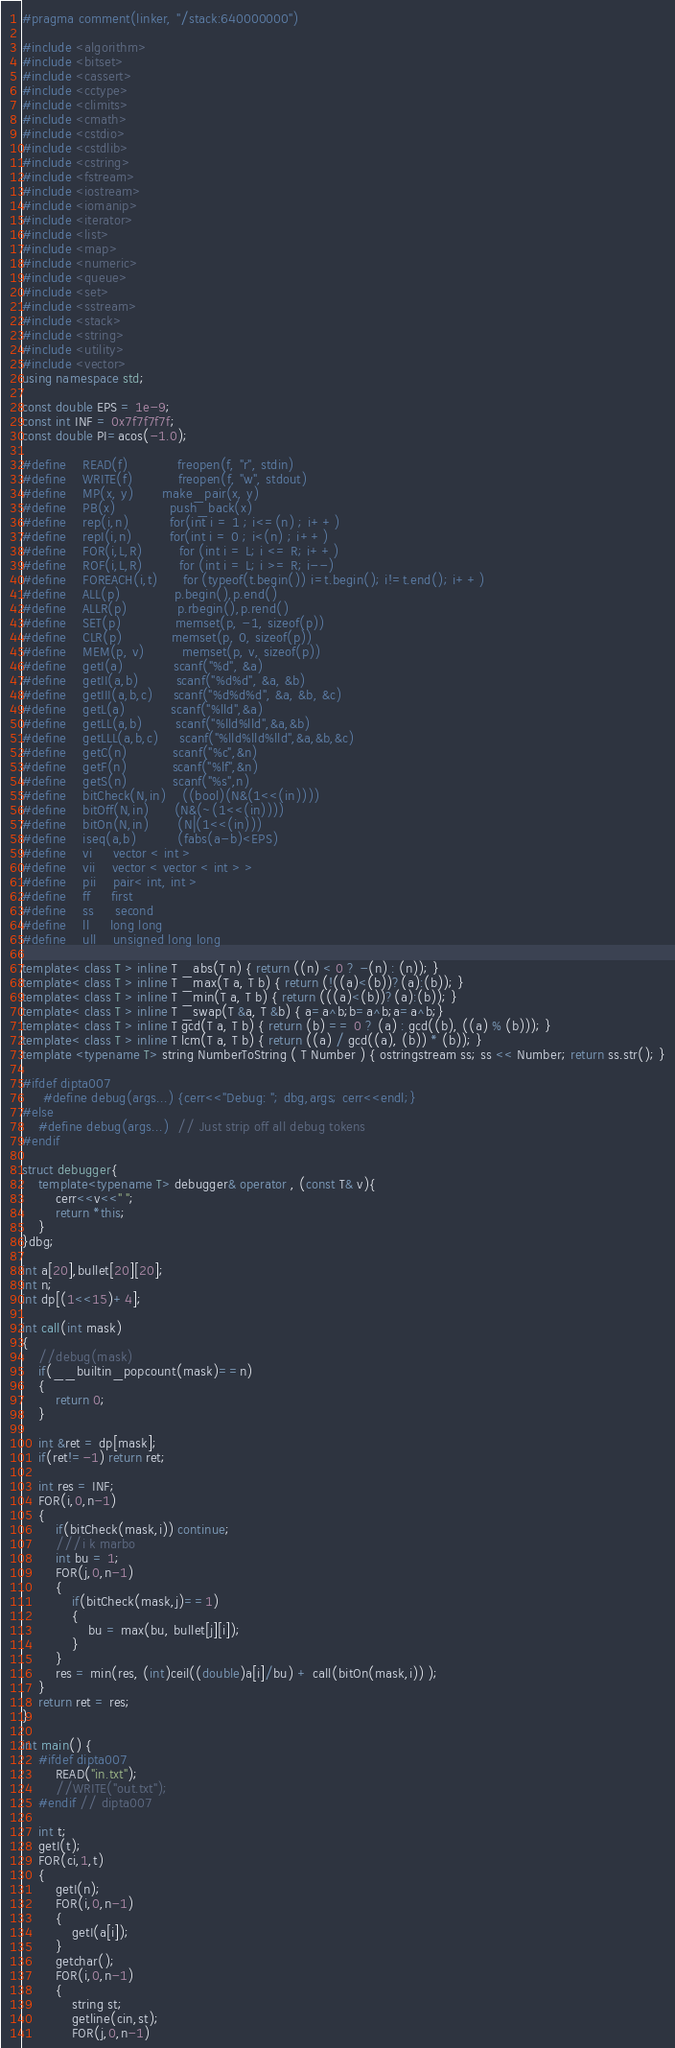Convert code to text. <code><loc_0><loc_0><loc_500><loc_500><_C++_>#pragma comment(linker, "/stack:640000000")

#include <algorithm>
#include <bitset>
#include <cassert>
#include <cctype>
#include <climits>
#include <cmath>
#include <cstdio>
#include <cstdlib>
#include <cstring>
#include <fstream>
#include <iostream>
#include <iomanip>
#include <iterator>
#include <list>
#include <map>
#include <numeric>
#include <queue>
#include <set>
#include <sstream>
#include <stack>
#include <string>
#include <utility>
#include <vector>
using namespace std;

const double EPS = 1e-9;
const int INF = 0x7f7f7f7f;
const double PI=acos(-1.0);

#define    READ(f) 	         freopen(f, "r", stdin)
#define    WRITE(f)   	     freopen(f, "w", stdout)
#define    MP(x, y) 	     make_pair(x, y)
#define    PB(x)             push_back(x)
#define    rep(i,n)          for(int i = 1 ; i<=(n) ; i++)
#define    repI(i,n)         for(int i = 0 ; i<(n) ; i++)
#define    FOR(i,L,R) 	     for (int i = L; i <= R; i++)
#define    ROF(i,L,R) 	     for (int i = L; i >= R; i--)
#define    FOREACH(i,t)      for (typeof(t.begin()) i=t.begin(); i!=t.end(); i++)
#define    ALL(p) 	         p.begin(),p.end()
#define    ALLR(p) 	         p.rbegin(),p.rend()
#define    SET(p) 	         memset(p, -1, sizeof(p))
#define    CLR(p)            memset(p, 0, sizeof(p))
#define    MEM(p, v)         memset(p, v, sizeof(p))
#define    getI(a) 	         scanf("%d", &a)
#define    getII(a,b) 	     scanf("%d%d", &a, &b)
#define    getIII(a,b,c)     scanf("%d%d%d", &a, &b, &c)
#define    getL(a)           scanf("%lld",&a)
#define    getLL(a,b)        scanf("%lld%lld",&a,&b)
#define    getLLL(a,b,c)     scanf("%lld%lld%lld",&a,&b,&c)
#define    getC(n)           scanf("%c",&n)
#define    getF(n)           scanf("%lf",&n)
#define    getS(n)           scanf("%s",n)
#define    bitCheck(N,in)    ((bool)(N&(1<<(in))))
#define    bitOff(N,in)      (N&(~(1<<(in))))
#define    bitOn(N,in)       (N|(1<<(in)))
#define    iseq(a,b)          (fabs(a-b)<EPS)
#define    vi 	 vector < int >
#define    vii 	 vector < vector < int > >
#define    pii 	 pair< int, int >
#define    ff 	 first
#define    ss 	 second
#define    ll	 long long
#define    ull 	 unsigned long long

template< class T > inline T _abs(T n) { return ((n) < 0 ? -(n) : (n)); }
template< class T > inline T _max(T a, T b) { return (!((a)<(b))?(a):(b)); }
template< class T > inline T _min(T a, T b) { return (((a)<(b))?(a):(b)); }
template< class T > inline T _swap(T &a, T &b) { a=a^b;b=a^b;a=a^b;}
template< class T > inline T gcd(T a, T b) { return (b) == 0 ? (a) : gcd((b), ((a) % (b))); }
template< class T > inline T lcm(T a, T b) { return ((a) / gcd((a), (b)) * (b)); }
template <typename T> string NumberToString ( T Number ) { ostringstream ss; ss << Number; return ss.str(); }

#ifdef dipta007
     #define debug(args...) {cerr<<"Debug: "; dbg,args; cerr<<endl;}
#else
    #define debug(args...)  // Just strip off all debug tokens
#endif

struct debugger{
    template<typename T> debugger& operator , (const T& v){
        cerr<<v<<" ";
        return *this;
    }
}dbg;

int a[20],bullet[20][20];
int n;
int dp[(1<<15)+4];

int call(int mask)
{
    //debug(mask)
    if(__builtin_popcount(mask)==n)
    {
        return 0;
    }

    int &ret = dp[mask];
    if(ret!=-1) return ret;

    int res = INF;
    FOR(i,0,n-1)
    {
        if(bitCheck(mask,i)) continue;
        ///i k marbo
        int bu = 1;
        FOR(j,0,n-1)
        {
            if(bitCheck(mask,j)==1)
            {
                bu = max(bu, bullet[j][i]);
            }
        }
        res = min(res, (int)ceil((double)a[i]/bu) + call(bitOn(mask,i)) );
    }
    return ret = res;
}

int main() {
    #ifdef dipta007
        READ("in.txt");
        //WRITE("out.txt");
    #endif // dipta007

    int t;
    getI(t);
    FOR(ci,1,t)
    {
        getI(n);
        FOR(i,0,n-1)
        {
            getI(a[i]);
        }
        getchar();
        FOR(i,0,n-1)
        {
            string st;
            getline(cin,st);
            FOR(j,0,n-1)</code> 